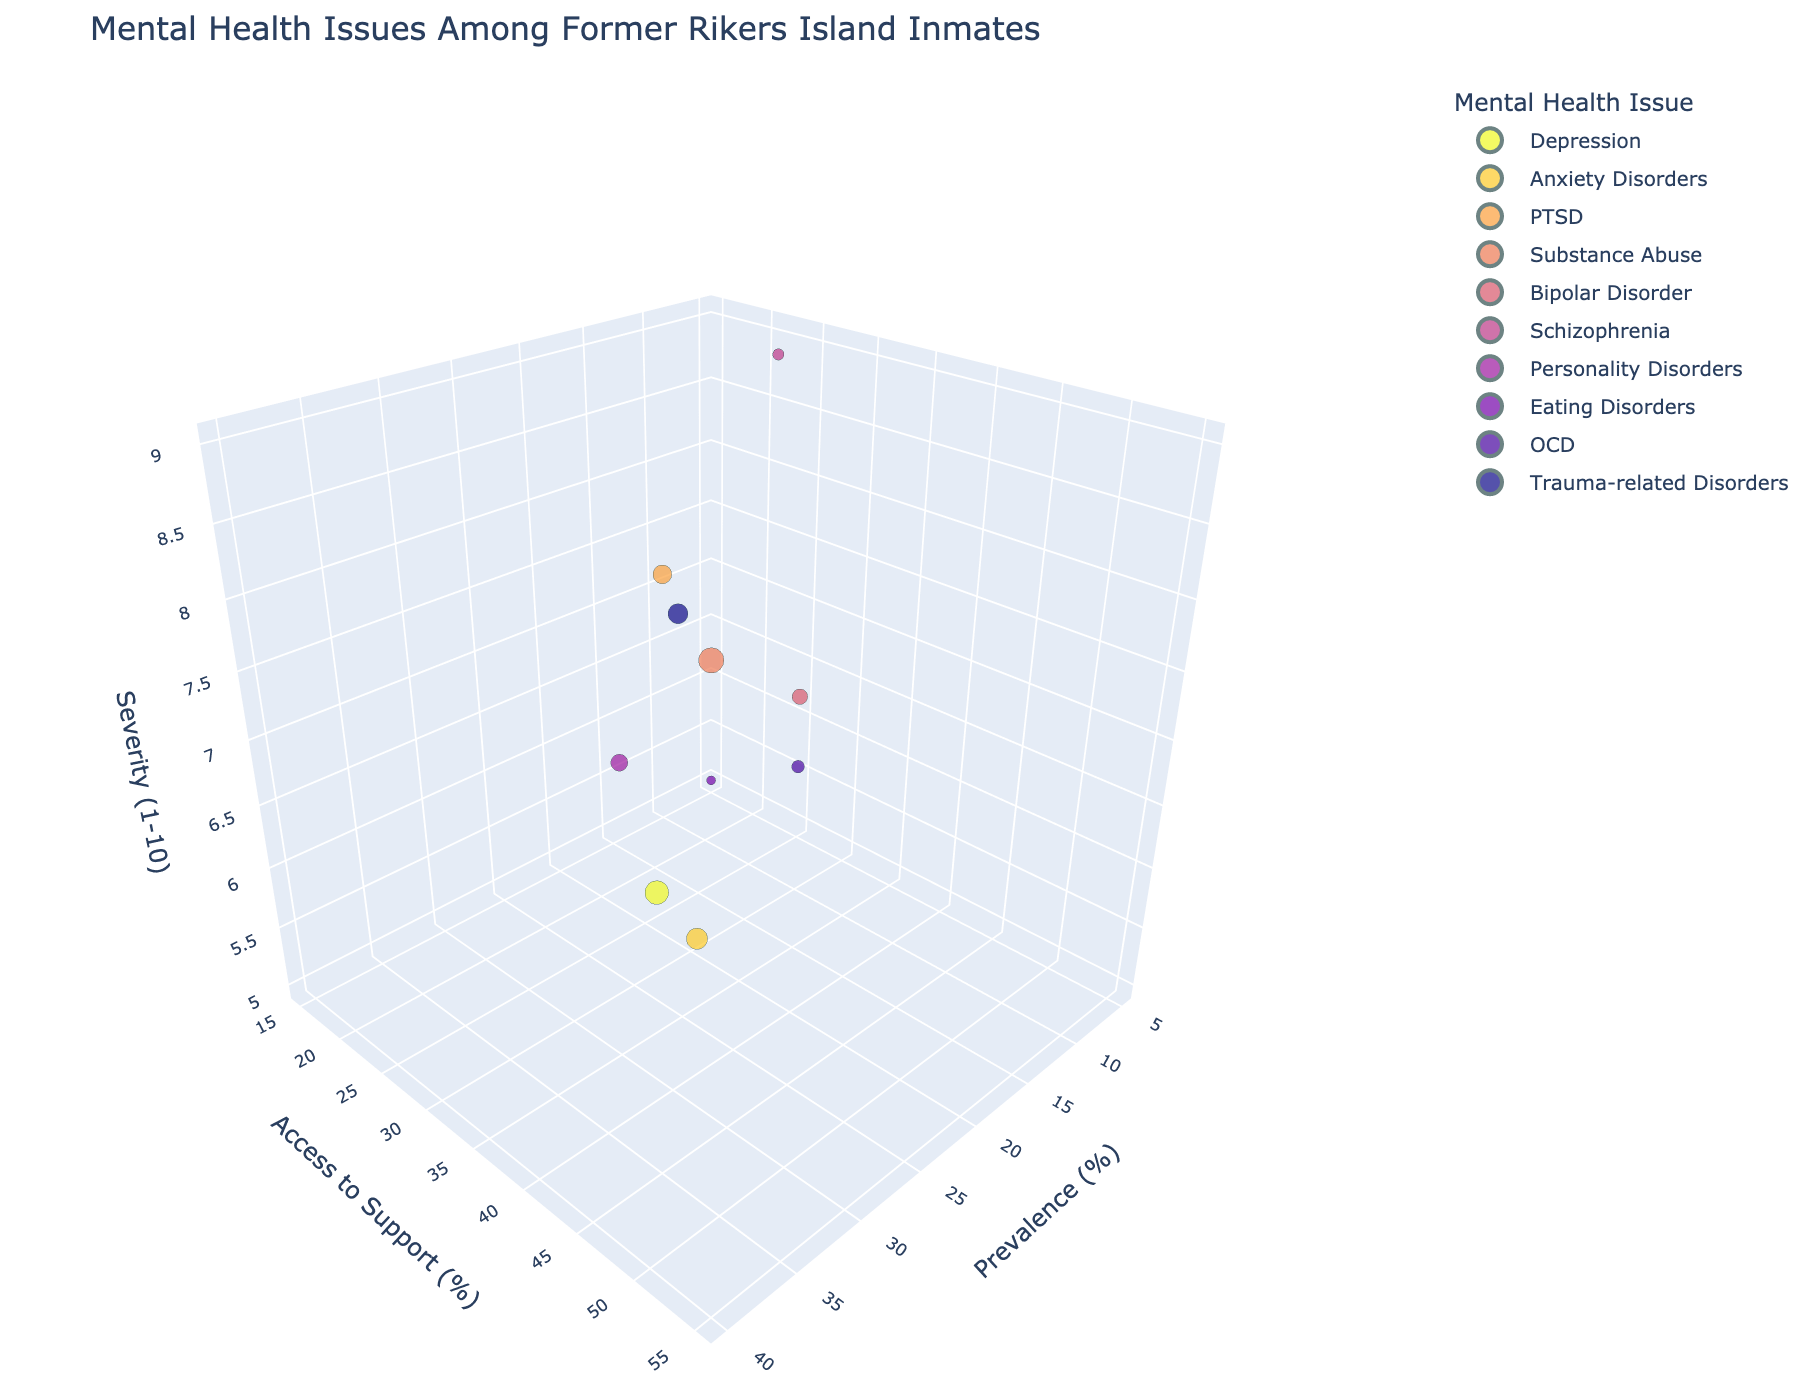What is the title of the figure? The title of the figure is usually displayed at the top. Here, it is "Mental Health Issues Among Former Rikers Island Inmates".
Answer: Mental Health Issues Among Former Rikers Island Inmates Which mental health issue has the highest prevalence? The prevalence (%) axis indicates how common each mental health issue is. By locating the bubble farthest along this axis, we see Substance Abuse at 40%.
Answer: Substance Abuse What is the range of severity scores presented in the figure? The severity (1-10) axis shows the range of severity scores. By examining the highest and lowest positions on this axis, we see the range is from 5 to 9.
Answer: 5 to 9 Which mental health issue has the lowest access to support percentage? The access to support (%) axis shows the level of access to support services. By finding the bubble closest to the beginning, we see Eating Disorders at 15%.
Answer: Eating Disorders Which mental health issues have equal severity scores? By looking at the severity axis and comparing the bubbles, we find Depression and Bipolar Disorder both have a severity score of 7.
Answer: Depression and Bipolar Disorder Which mental health issue has the highest severity combined with the highest prevalence? To determine this, we need to locate the highest prevalence along the prevalence axis and the highest severity along the severity axis. Substance Abuse has the highest prevalence and also has a high severity score of 9.
Answer: Substance Abuse Which mental health issue has the largest bubble size with the highest access to support? The size of the bubble refers to prevalence, and we look for the largest bubble under high access to support. Substance Abuse with 55% access support and is the largest indicates it also has the highest prevalence.
Answer: Substance Abuse What is the median access to support percentage for the listed mental health issues? To find the median, list the access percentages in ascending order and find the middle value. The values in order are 15, 20, 25, 30, 30, 35, 35, 40, 45, 55. The middle values are 30 and 35, so the median is (30+35)/2 = 32.5
Answer: 32.5 How does the prevalence of PTSD compare to Anxiety Disorders? By comparing their positions along the prevalence axis, PTSD has a prevalence of 22% while Anxiety Disorders has 28%. Anxiety Disorders has a higher prevalence.
Answer: Anxiety Disorders Which mental health issue has the smallest bubble size but a relatively high severity score? The smallest bubble size indicates the lowest prevalence. Starting from the severity axis, we find Eating Disorders has the smallest bubble size with a severity score of 5.
Answer: Eating Disorders 